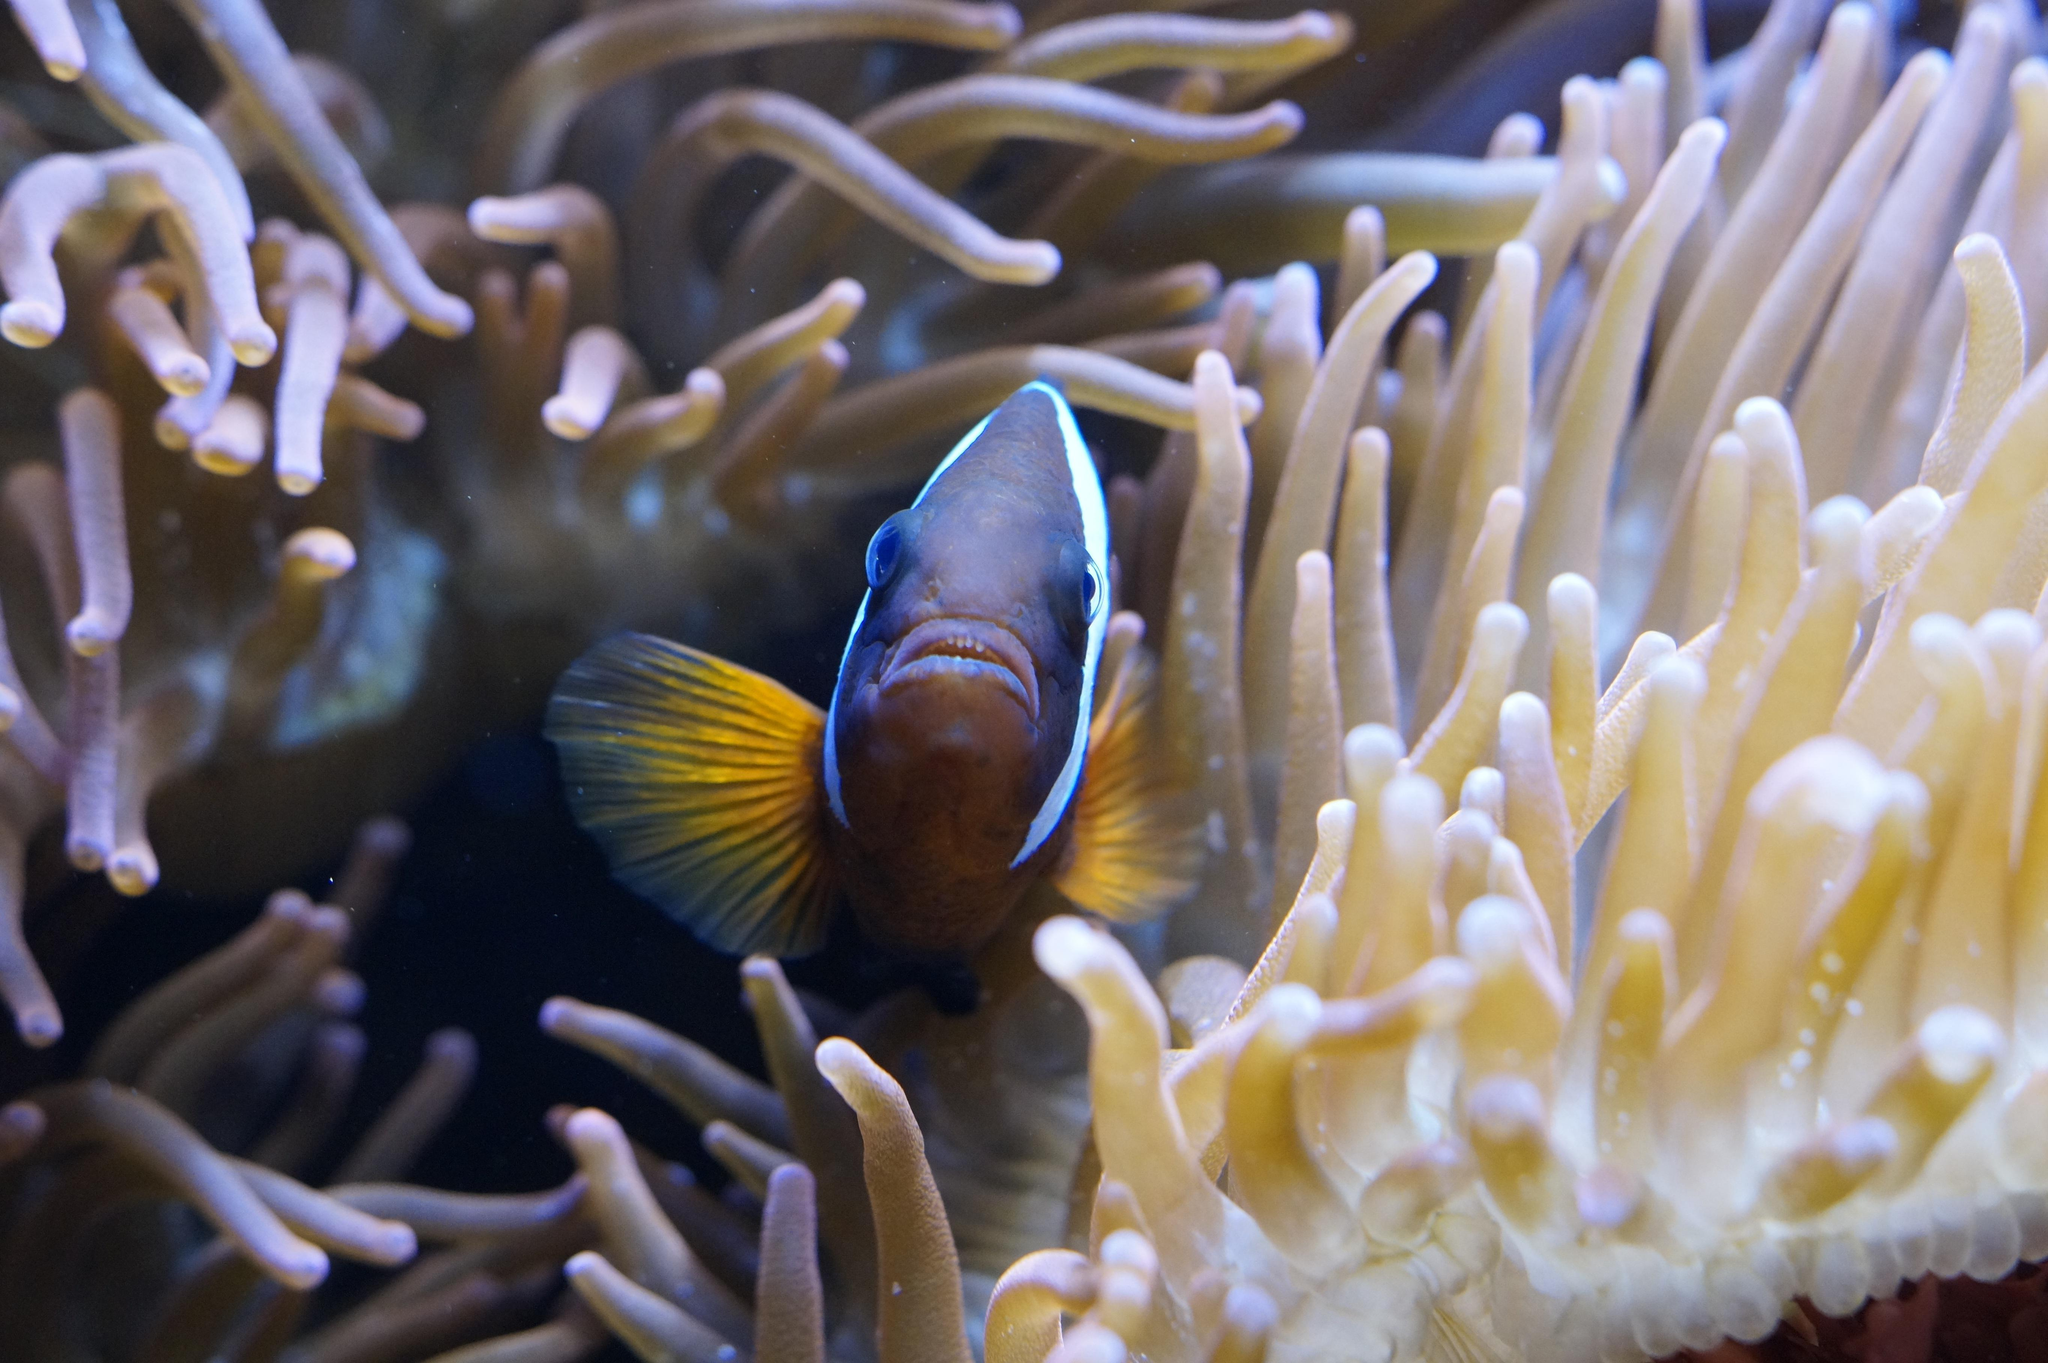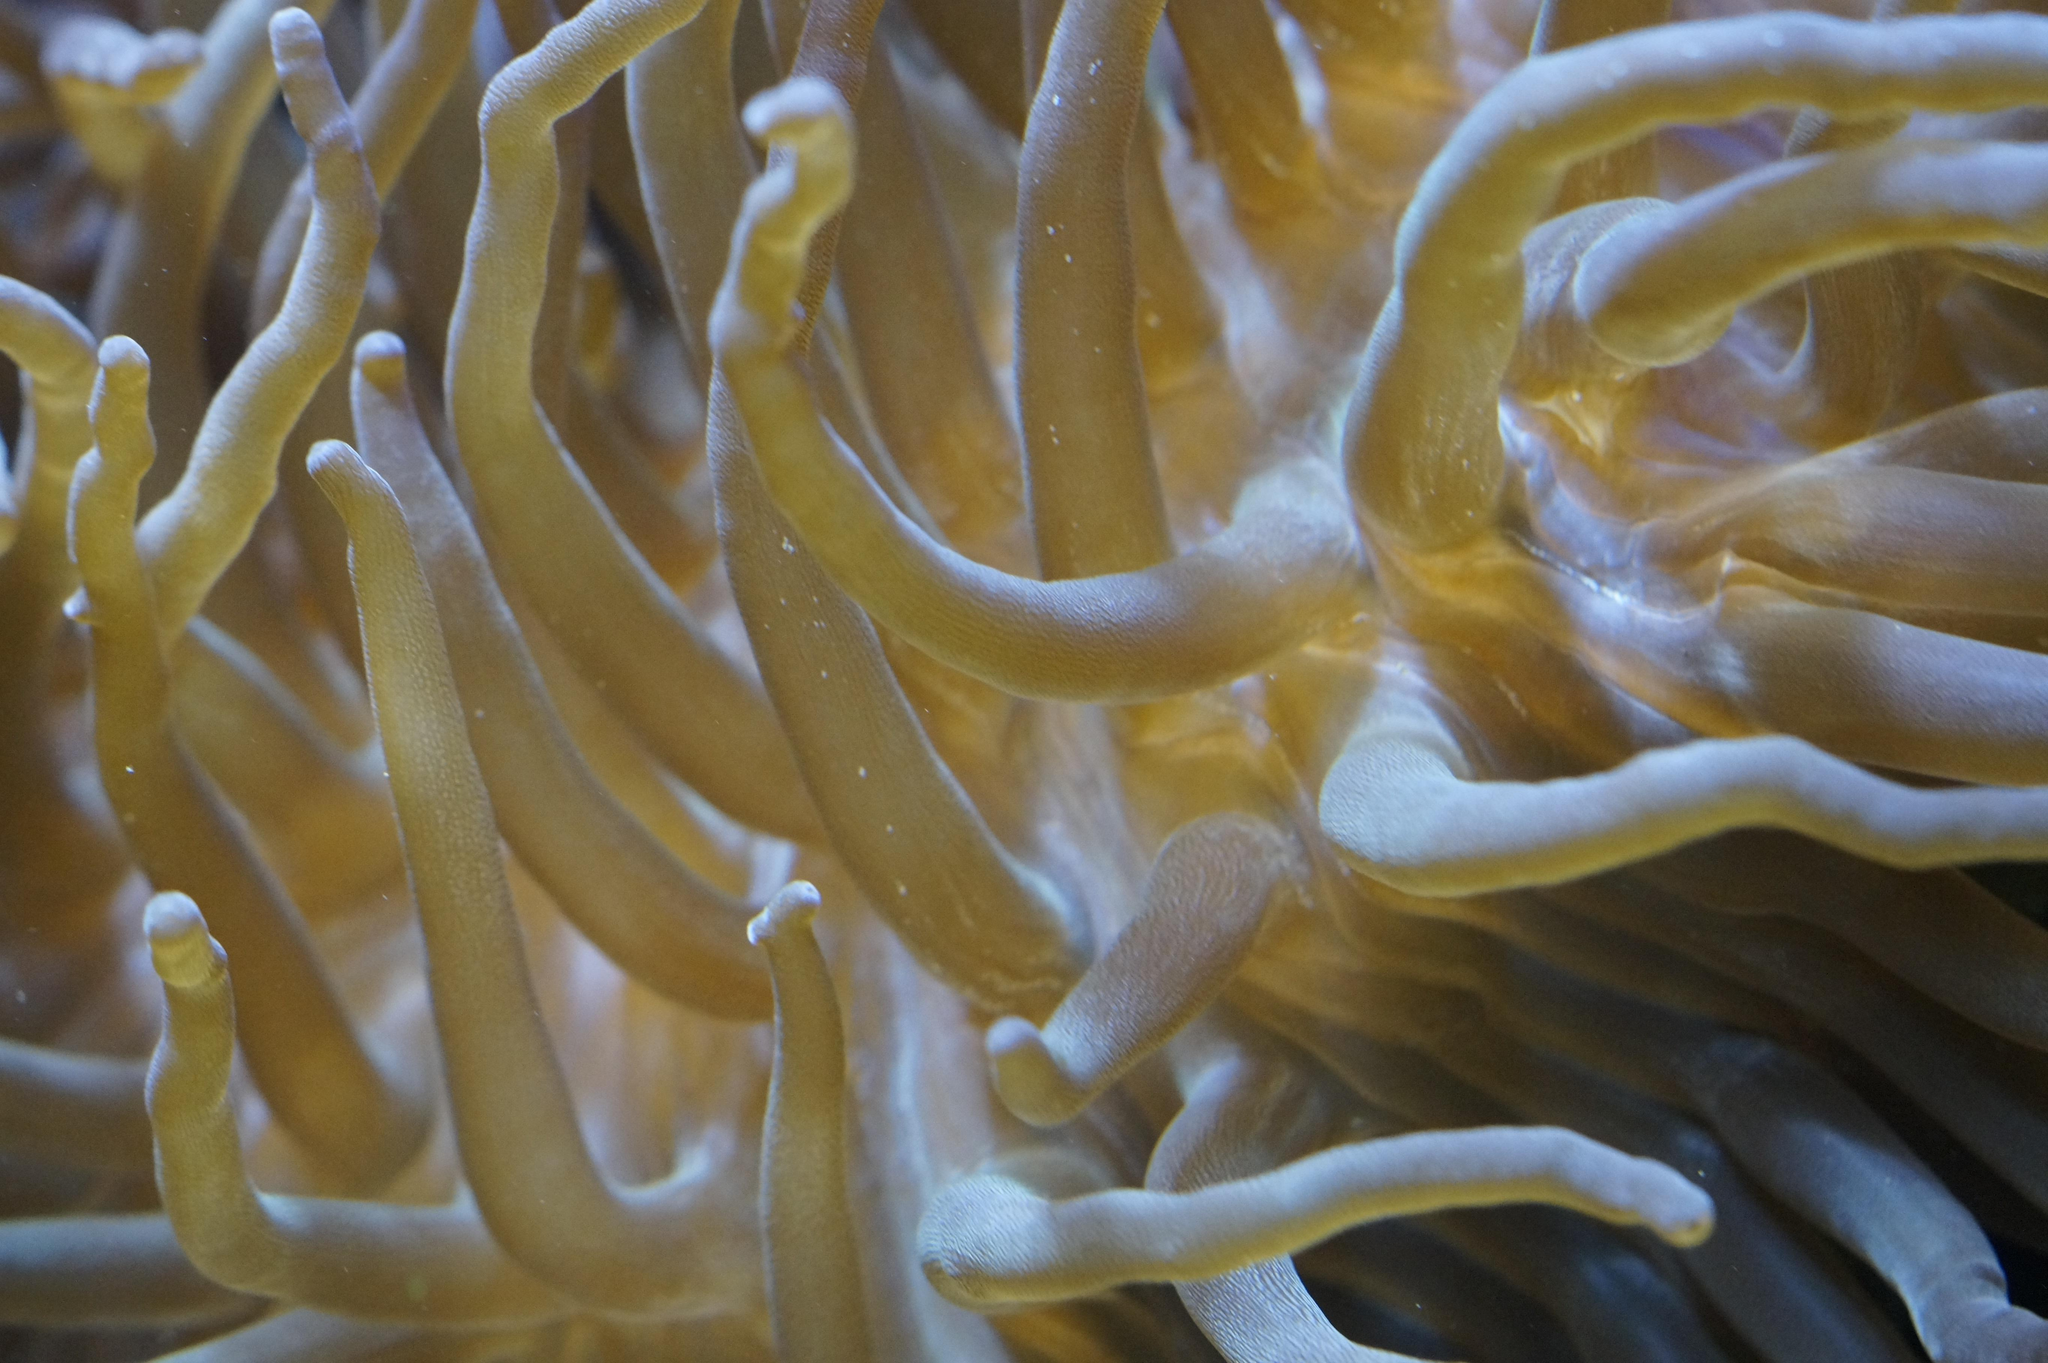The first image is the image on the left, the second image is the image on the right. Evaluate the accuracy of this statement regarding the images: "The left image contains an animal that is not an anemone.". Is it true? Answer yes or no. Yes. The first image is the image on the left, the second image is the image on the right. Examine the images to the left and right. Is the description "At least one anemone image looks like spaghetti noodles rather than a flower shape." accurate? Answer yes or no. Yes. 